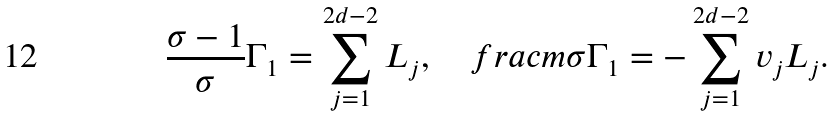<formula> <loc_0><loc_0><loc_500><loc_500>\frac { \sigma - 1 } { \sigma } \Gamma _ { 1 } = \sum _ { j = 1 } ^ { 2 d - 2 } L _ { j } , \quad f r a c { m } { \sigma } \Gamma _ { 1 } = - \sum _ { j = 1 } ^ { 2 d - 2 } v _ { j } L _ { j } .</formula> 